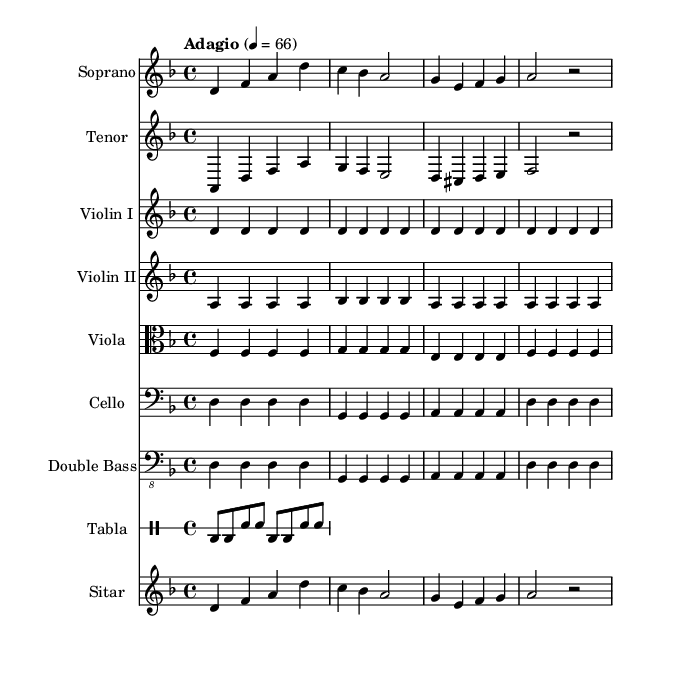What is the key signature of this music? The key signature indicated in the music is D minor, which is represented by one flat (B♭). This is confirmed by the initial 'key d \minor' statement in the code.
Answer: D minor What is the time signature of this music? The time signature shown in the music is 4/4, which means there are four beats in each measure. This is represented as ' \time 4/4' in the code section.
Answer: 4/4 What is the tempo marking of this music? The tempo marking indicates "Adagio," which suggests a slow tempo. This is specified by ' \tempo "Adagio" 4 = 66' in the music.
Answer: Adagio Which instruments are included in this score? The instruments listed in the score are Soprano, Tenor, Violin I, Violin II, Viola, Cello, Double Bass, Tabla, and Sitar. Each instrument is shown under a new staff in the code.
Answer: Soprano, Tenor, Violin I, Violin II, Viola, Cello, Double Bass, Tabla, Sitar How many measures are in the Soprano part? The Soprano part contains four measures, as indicated by the sequence of notes grouped by bar lines. A careful visual inspection of the music shows four distinct groupings of notes.
Answer: 4 What is the rhythmic pattern of the Tabla? The Tabla part consists of a series of eighth notes and snare notes, specifically following the pattern of two bass notes followed by two snare hits. This pattern can be traced from the 'drummode' section in the score.
Answer: bd8 bd sn sn 